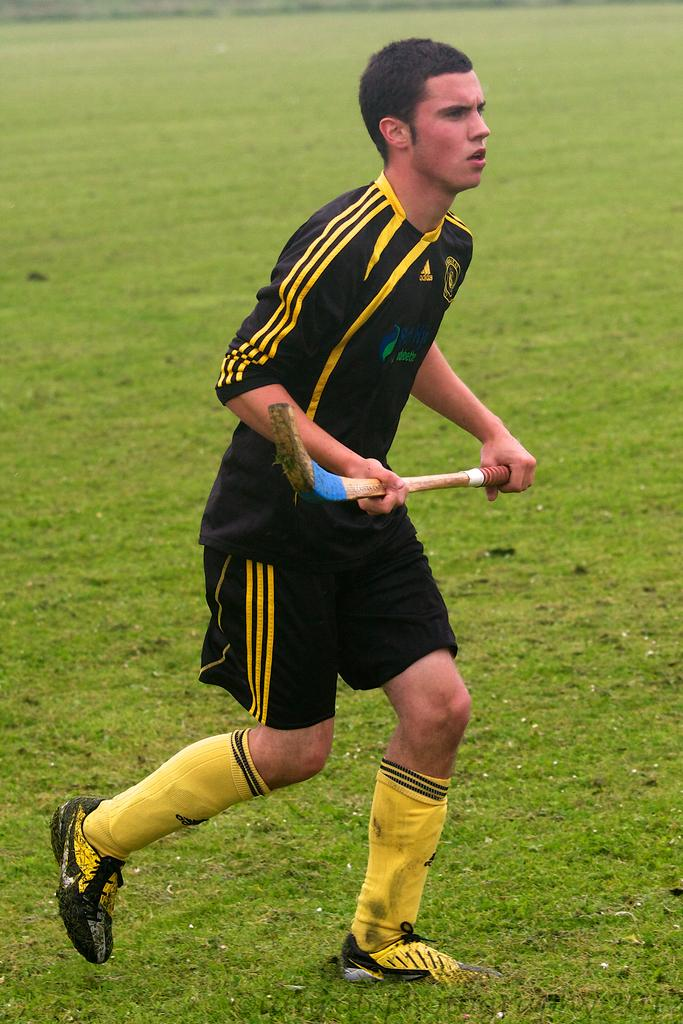Who or what is present in the image? There is a person in the image. What is the person doing in the image? The person is standing on the ground. What object is the person holding in the image? The person is holding a bat. What type of trick can be seen being performed with the bat in the image? There is no trick being performed with the bat in the image; the person is simply holding it. 